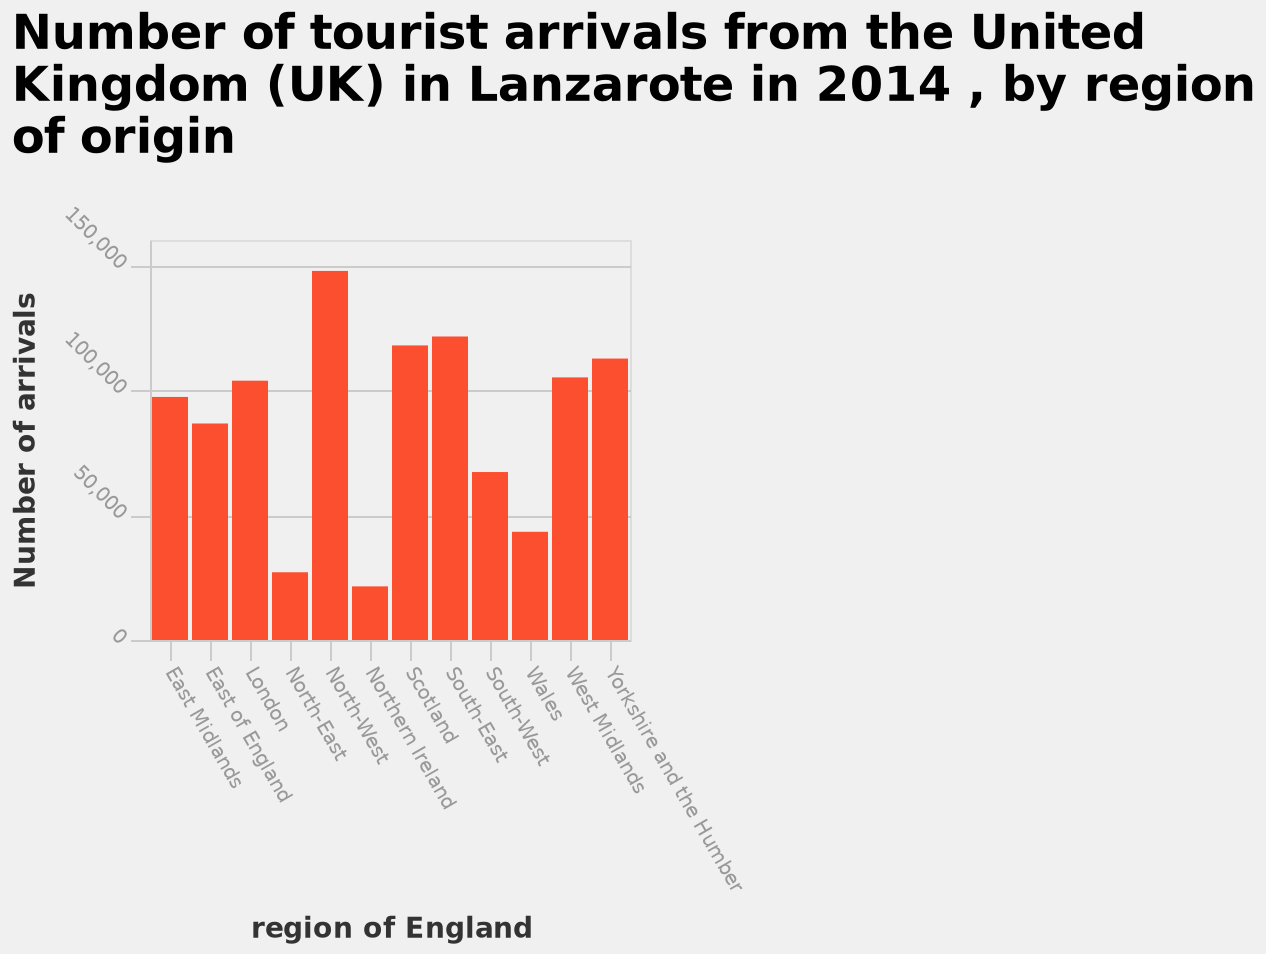<image>
please enumerates aspects of the construction of the chart Here a bar graph is named Number of tourist arrivals from the United Kingdom (UK) in Lanzarote in 2014 , by region of origin. The y-axis measures Number of arrivals while the x-axis plots region of England. 